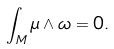Convert formula to latex. <formula><loc_0><loc_0><loc_500><loc_500>\int _ { M } \mu \wedge \omega = 0 .</formula> 